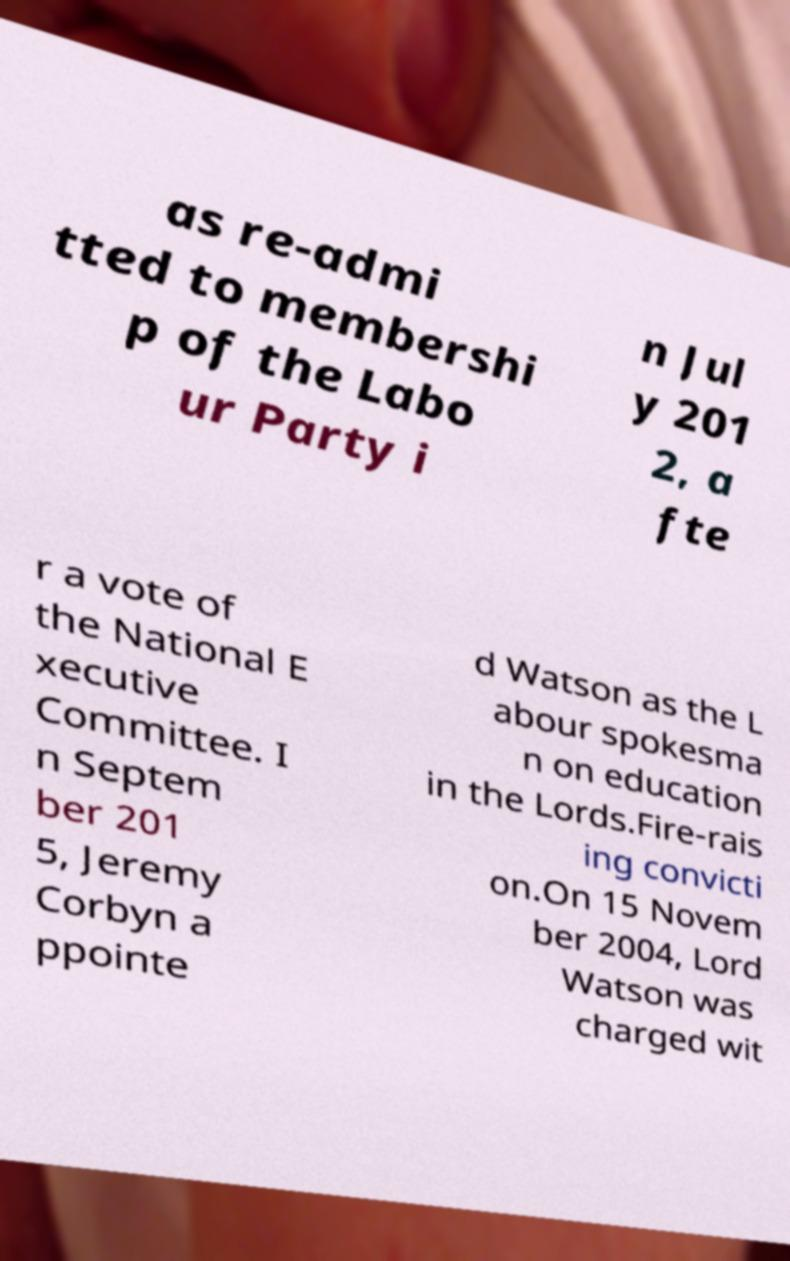I need the written content from this picture converted into text. Can you do that? as re-admi tted to membershi p of the Labo ur Party i n Jul y 201 2, a fte r a vote of the National E xecutive Committee. I n Septem ber 201 5, Jeremy Corbyn a ppointe d Watson as the L abour spokesma n on education in the Lords.Fire-rais ing convicti on.On 15 Novem ber 2004, Lord Watson was charged wit 